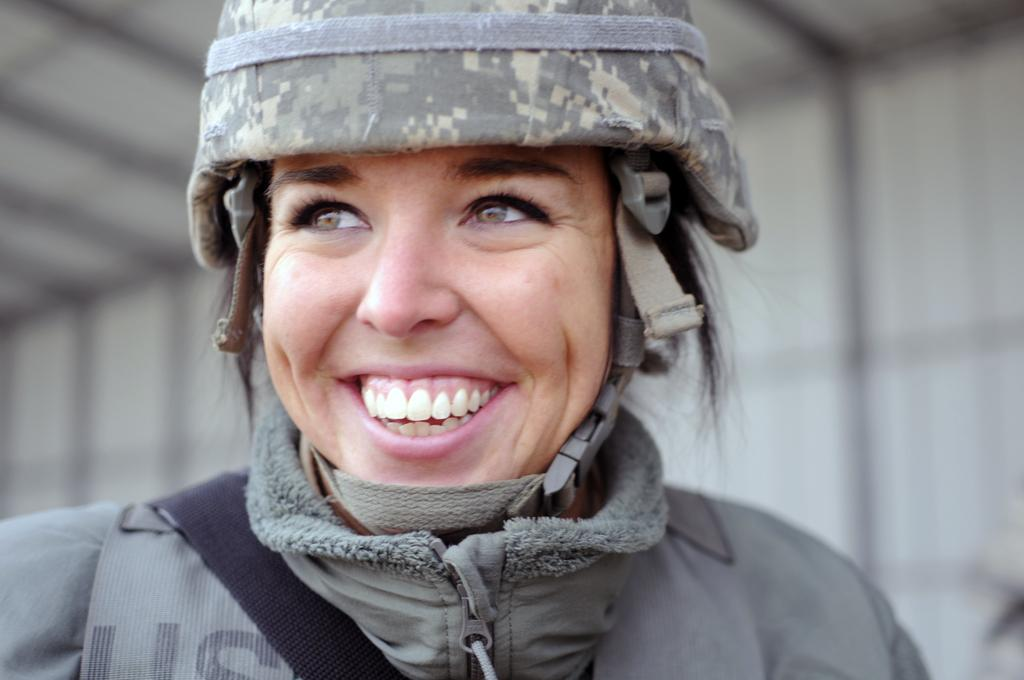Who is the main subject in the image? There is a lady in the image. What is the lady wearing on her upper body? The lady is wearing a sweater. What type of headwear is the lady wearing? The lady is wearing a hat. Can you describe the background of the image? The background of the image is blurred. What type of mine can be seen in the background of the image? There is no mine present in the image; the background is blurred. How does the acoustics of the lady's voice change due to her clothing? The lady's clothing, specifically the sweater and hat, do not affect the acoustics of her voice. 